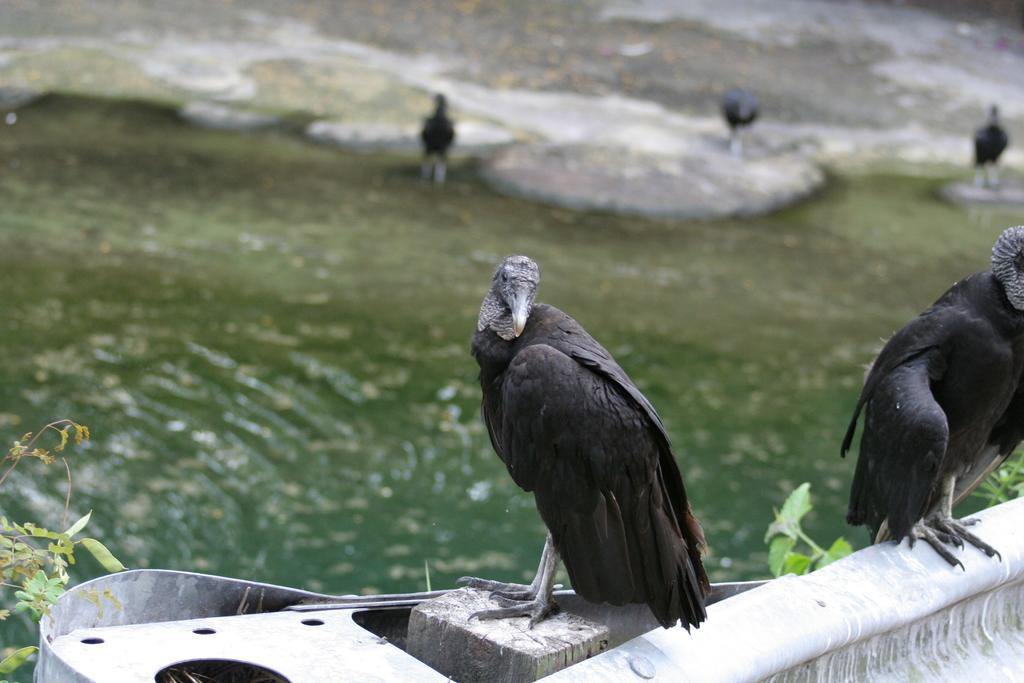In one or two sentences, can you explain what this image depicts? This image consists of water in the middle. There are eagles in the middle. There are plants on the left side. 